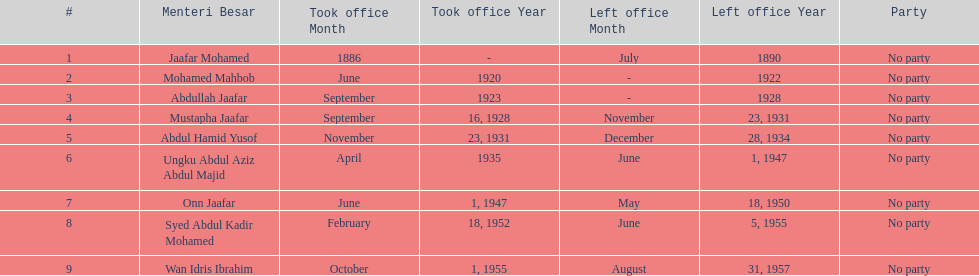Other than abullah jaafar, name someone with the same last name. Mustapha Jaafar. 